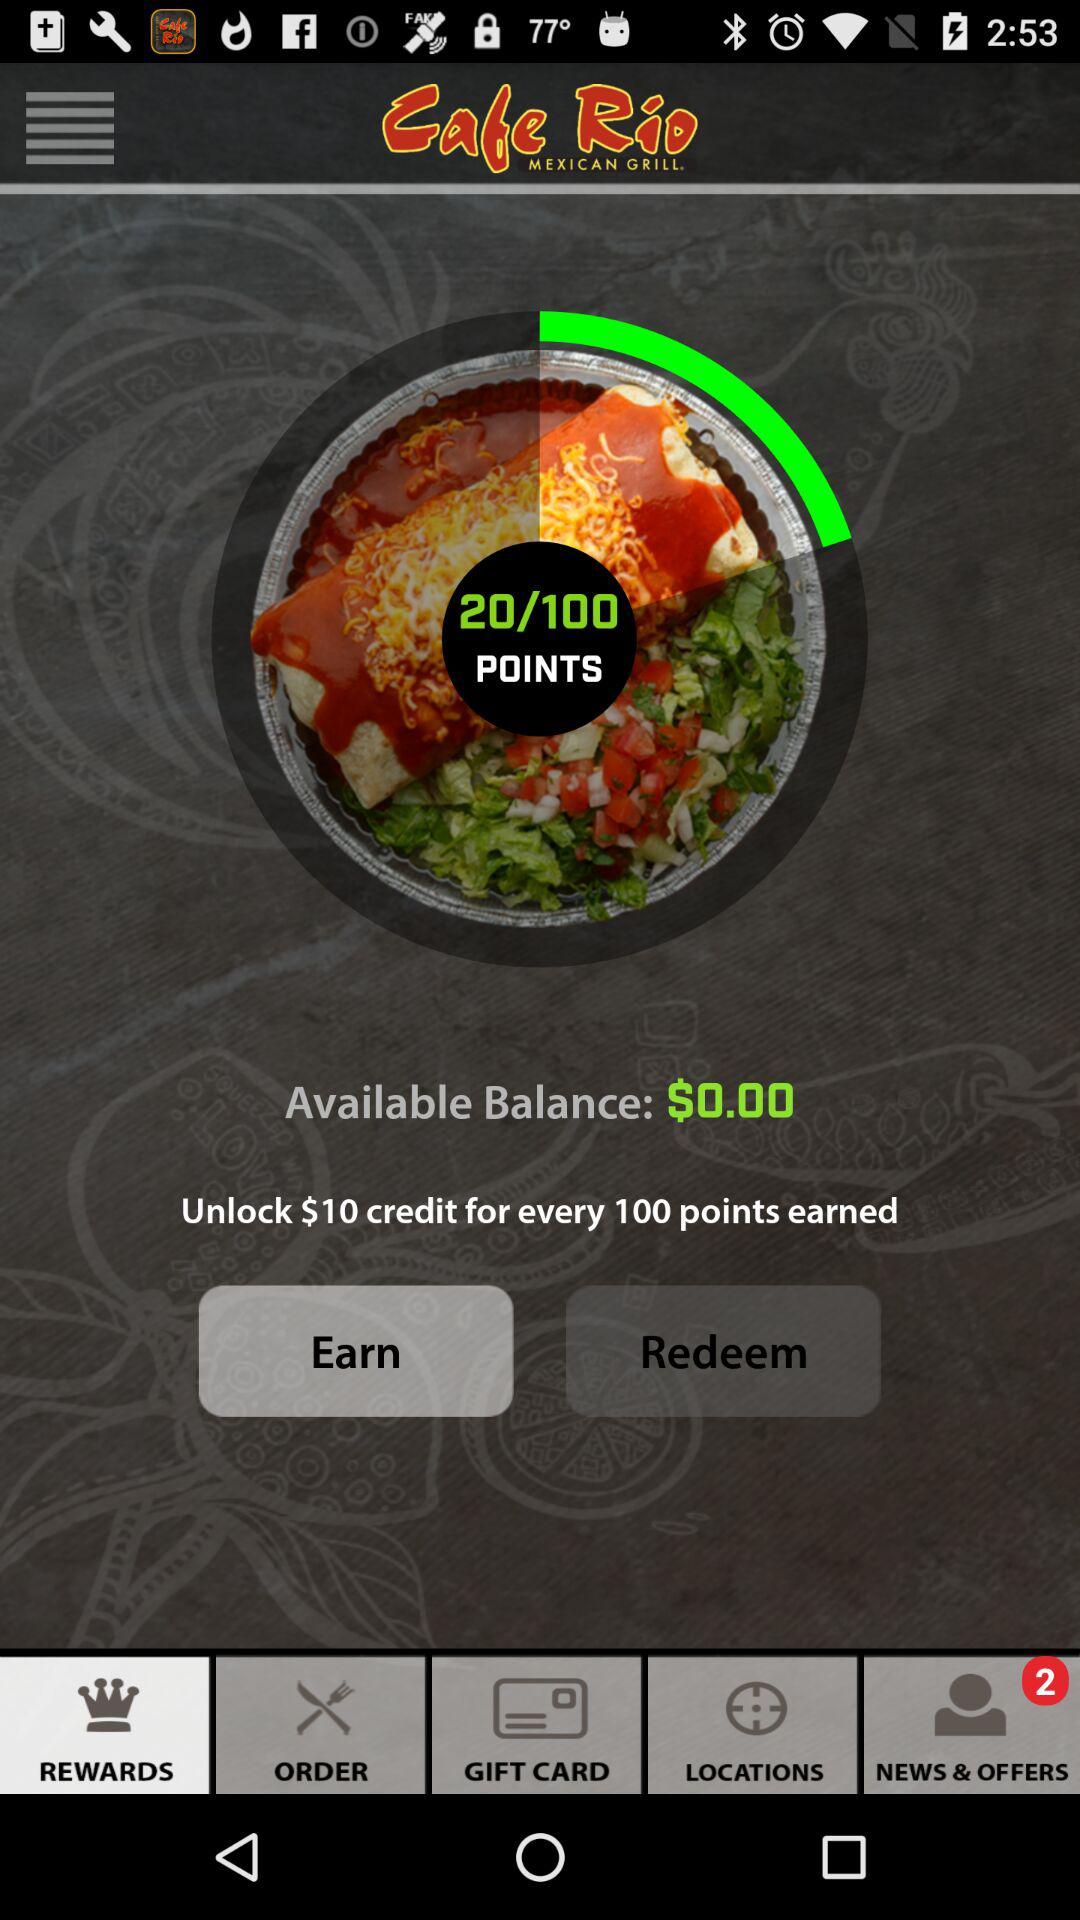How many points do I need to earn in order to redeem a $10 credit?
Answer the question using a single word or phrase. 100 